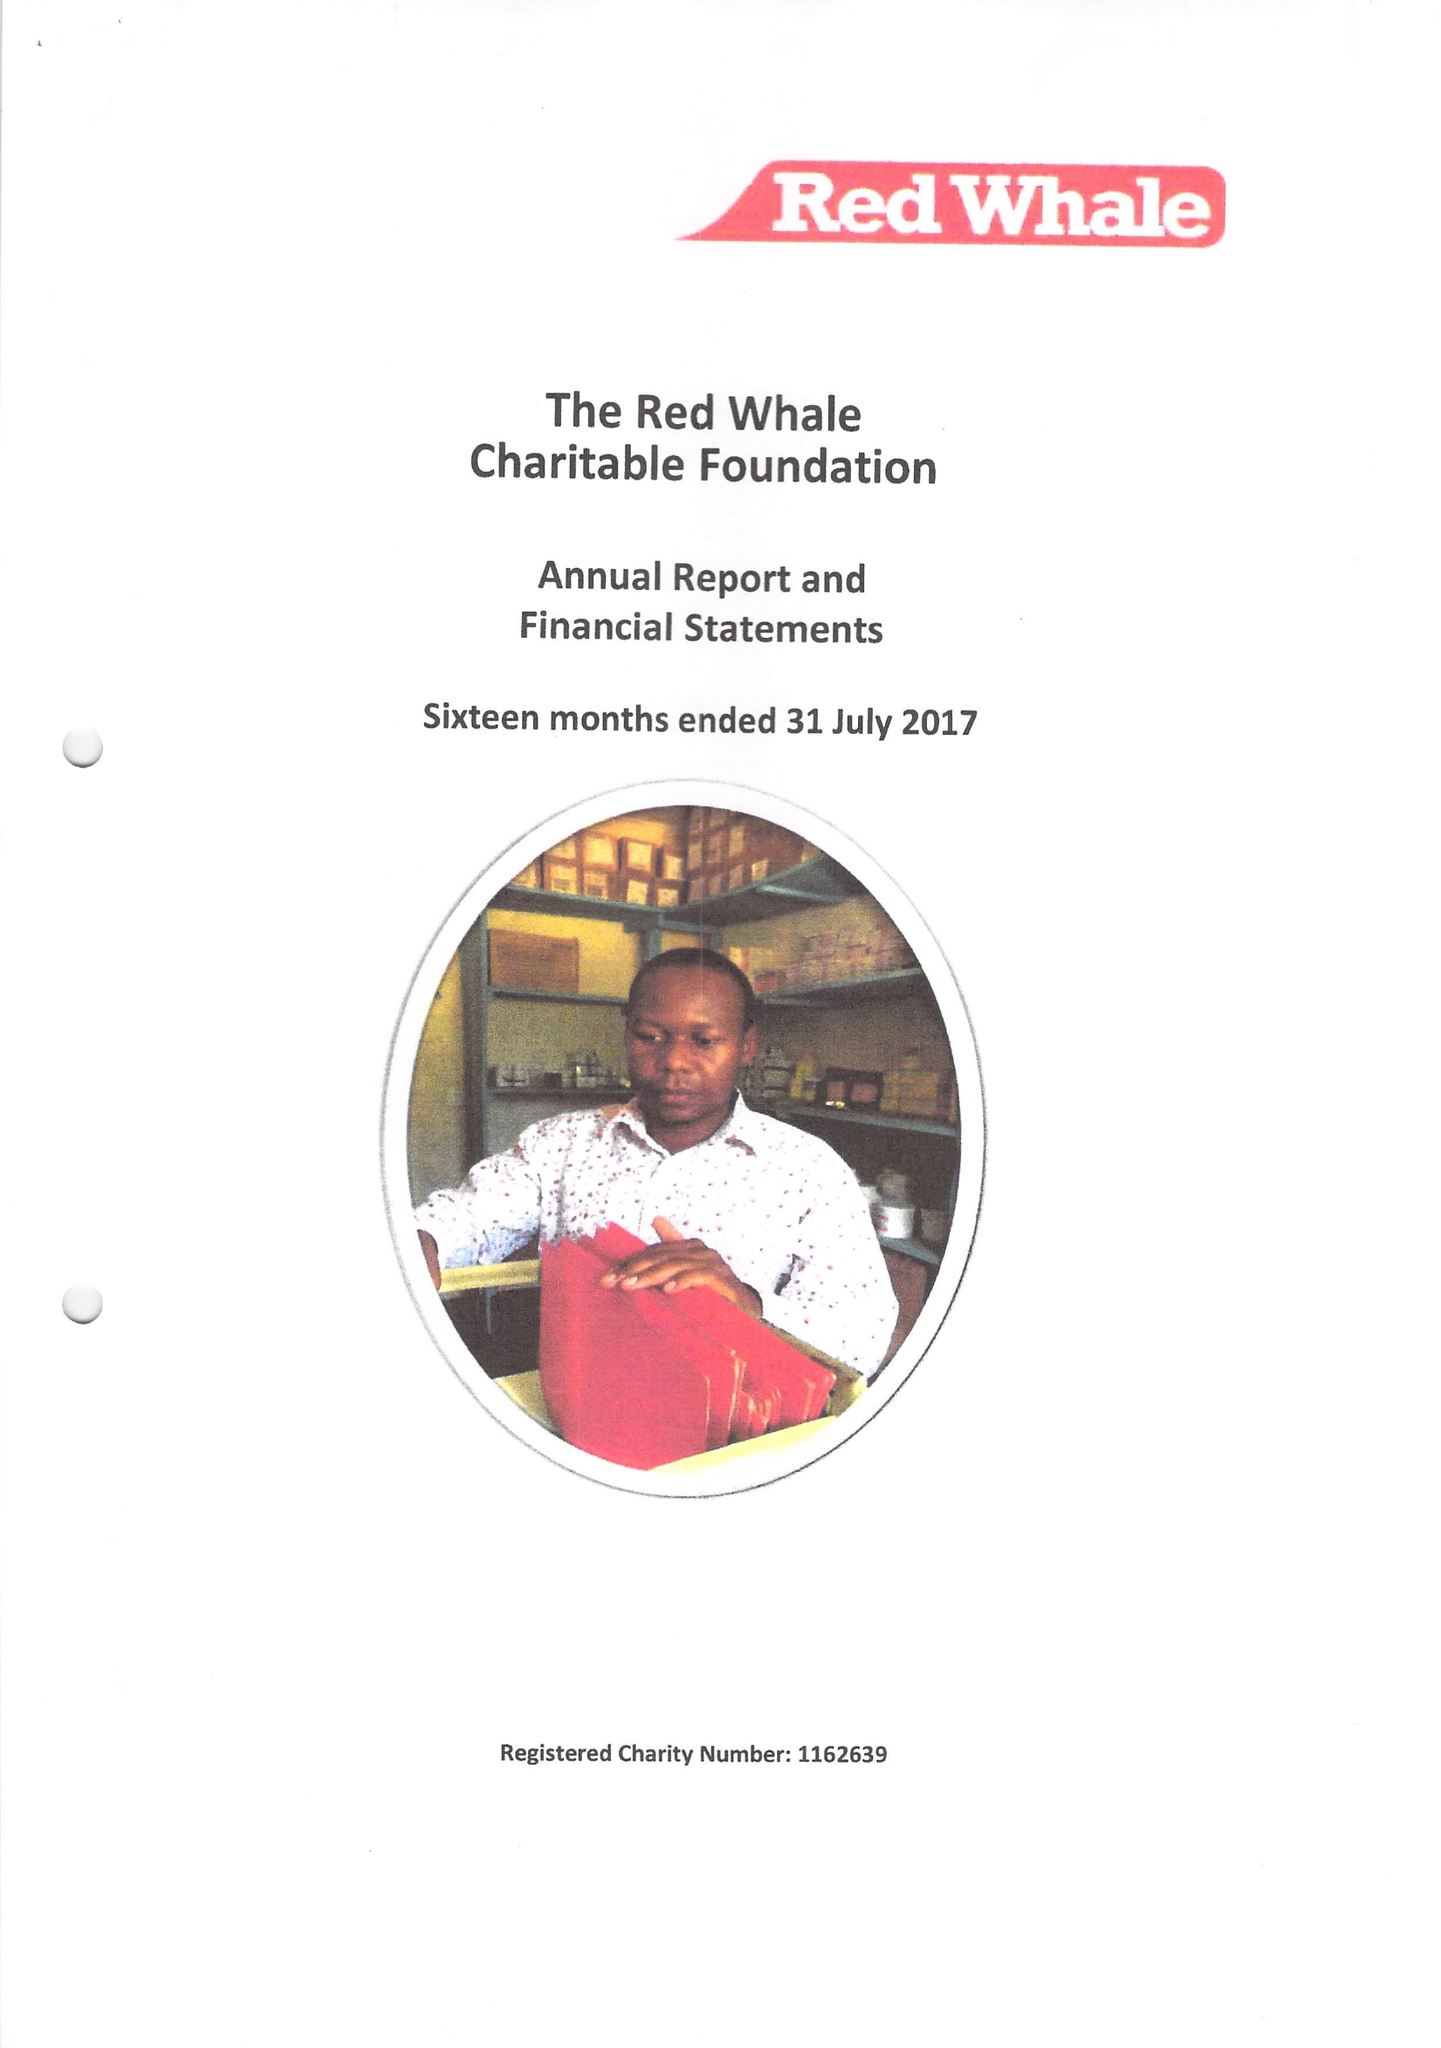What is the value for the charity_number?
Answer the question using a single word or phrase. 1162639 